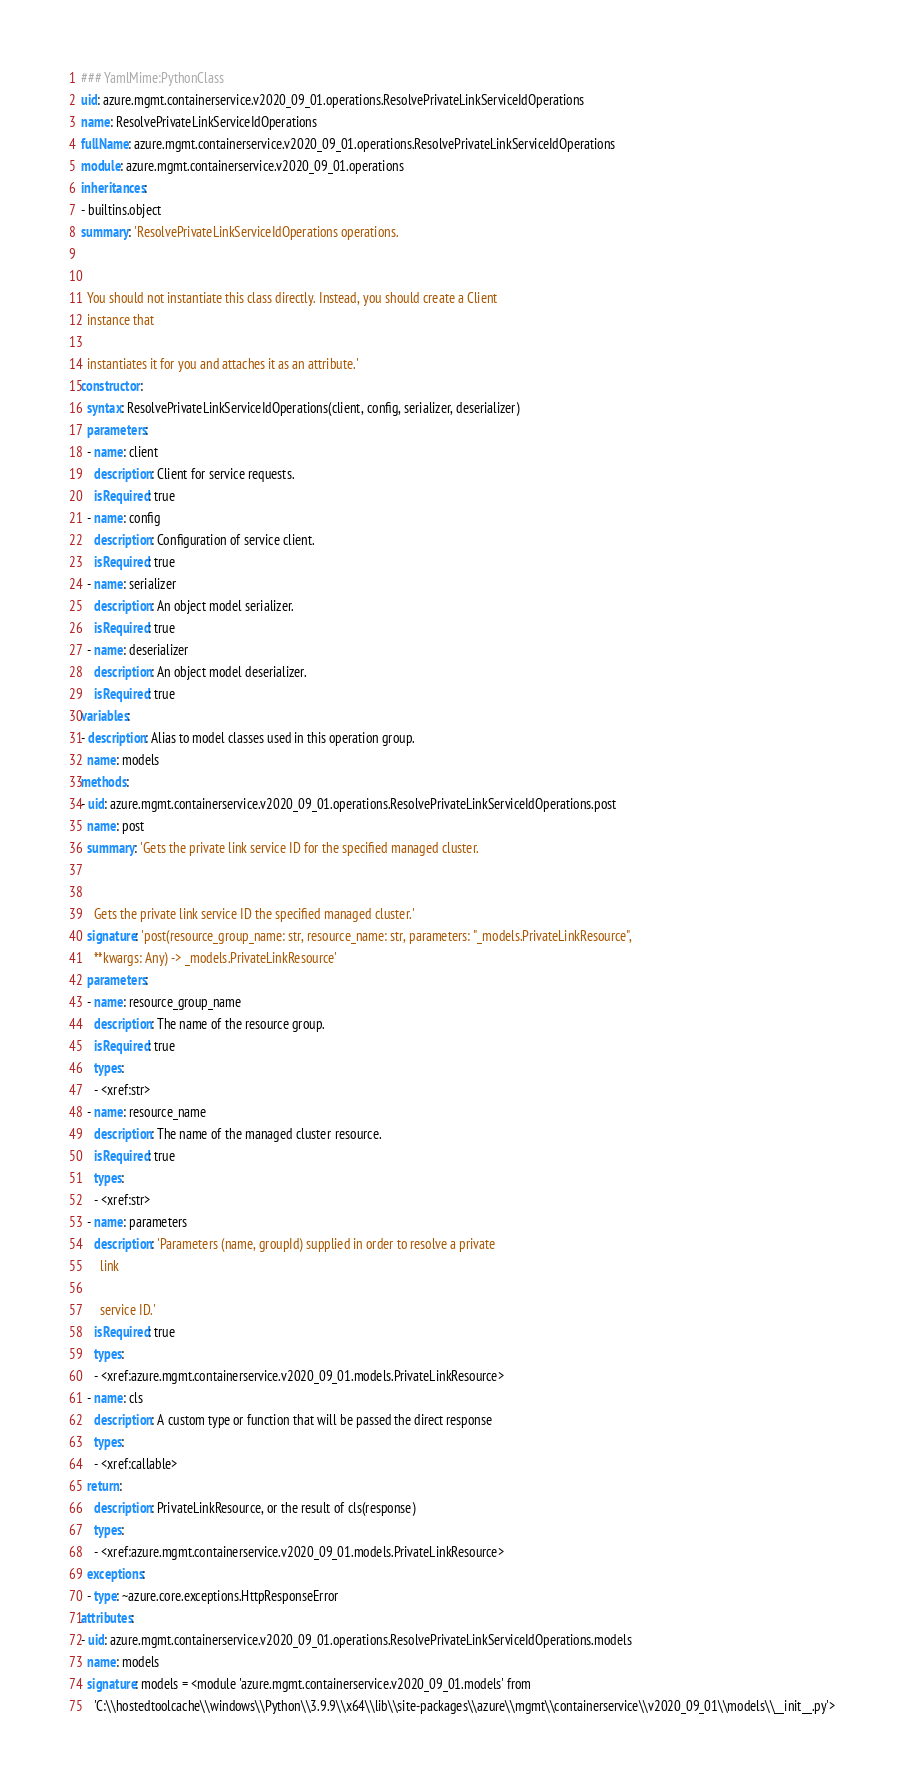Convert code to text. <code><loc_0><loc_0><loc_500><loc_500><_YAML_>### YamlMime:PythonClass
uid: azure.mgmt.containerservice.v2020_09_01.operations.ResolvePrivateLinkServiceIdOperations
name: ResolvePrivateLinkServiceIdOperations
fullName: azure.mgmt.containerservice.v2020_09_01.operations.ResolvePrivateLinkServiceIdOperations
module: azure.mgmt.containerservice.v2020_09_01.operations
inheritances:
- builtins.object
summary: 'ResolvePrivateLinkServiceIdOperations operations.


  You should not instantiate this class directly. Instead, you should create a Client
  instance that

  instantiates it for you and attaches it as an attribute.'
constructor:
  syntax: ResolvePrivateLinkServiceIdOperations(client, config, serializer, deserializer)
  parameters:
  - name: client
    description: Client for service requests.
    isRequired: true
  - name: config
    description: Configuration of service client.
    isRequired: true
  - name: serializer
    description: An object model serializer.
    isRequired: true
  - name: deserializer
    description: An object model deserializer.
    isRequired: true
variables:
- description: Alias to model classes used in this operation group.
  name: models
methods:
- uid: azure.mgmt.containerservice.v2020_09_01.operations.ResolvePrivateLinkServiceIdOperations.post
  name: post
  summary: 'Gets the private link service ID for the specified managed cluster.


    Gets the private link service ID the specified managed cluster.'
  signature: 'post(resource_group_name: str, resource_name: str, parameters: "_models.PrivateLinkResource",
    **kwargs: Any) -> _models.PrivateLinkResource'
  parameters:
  - name: resource_group_name
    description: The name of the resource group.
    isRequired: true
    types:
    - <xref:str>
  - name: resource_name
    description: The name of the managed cluster resource.
    isRequired: true
    types:
    - <xref:str>
  - name: parameters
    description: 'Parameters (name, groupId) supplied in order to resolve a private
      link

      service ID.'
    isRequired: true
    types:
    - <xref:azure.mgmt.containerservice.v2020_09_01.models.PrivateLinkResource>
  - name: cls
    description: A custom type or function that will be passed the direct response
    types:
    - <xref:callable>
  return:
    description: PrivateLinkResource, or the result of cls(response)
    types:
    - <xref:azure.mgmt.containerservice.v2020_09_01.models.PrivateLinkResource>
  exceptions:
  - type: ~azure.core.exceptions.HttpResponseError
attributes:
- uid: azure.mgmt.containerservice.v2020_09_01.operations.ResolvePrivateLinkServiceIdOperations.models
  name: models
  signature: models = <module 'azure.mgmt.containerservice.v2020_09_01.models' from
    'C:\\hostedtoolcache\\windows\\Python\\3.9.9\\x64\\lib\\site-packages\\azure\\mgmt\\containerservice\\v2020_09_01\\models\\__init__.py'>
</code> 